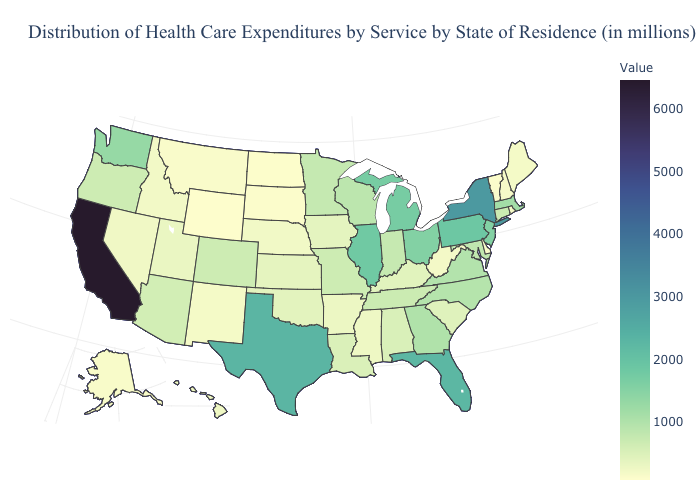Does Virginia have a lower value than Maine?
Write a very short answer. No. Does Iowa have a lower value than Michigan?
Concise answer only. Yes. Does Vermont have the lowest value in the Northeast?
Be succinct. Yes. Which states have the highest value in the USA?
Be succinct. California. Does Texas have the highest value in the South?
Answer briefly. Yes. Among the states that border Alabama , does Florida have the highest value?
Write a very short answer. Yes. Among the states that border California , does Arizona have the lowest value?
Answer briefly. No. 